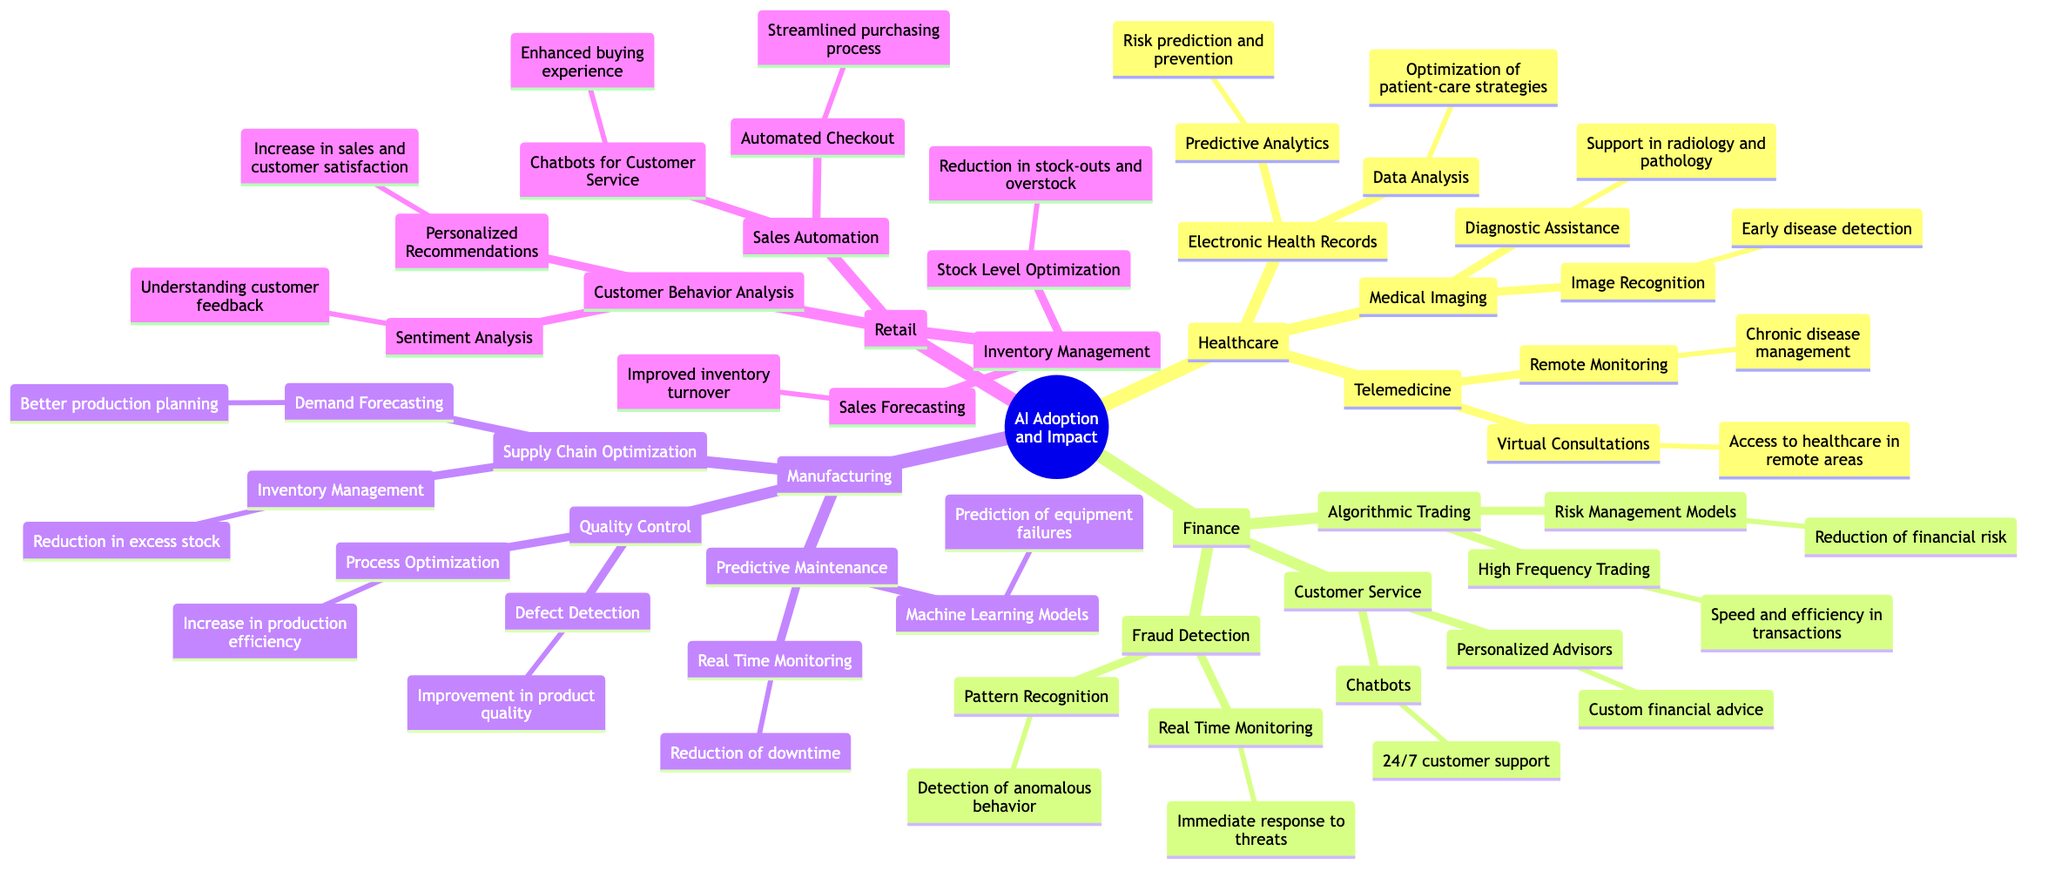What is one application of AI in healthcare? The diagram shows several applications in healthcare under various categories. One application listed is "Optimization of patient-care strategies," which falls under Electronic Health Records.
Answer: Optimization of patient-care strategies How many main industries are represented in the diagram? By looking at the root category, we can identify four main industries: Healthcare, Finance, Manufacturing, and Retail. Therefore, we count these categories.
Answer: Four Which sub-element in Finance is focused on immediate responses to threats? We can trace through the Finance section. In Fraud Detection, one of the sub-elements is "Real Time Monitoring," which is explicitly stated to provide immediate responses to threats.
Answer: Real Time Monitoring What is a key focus of Customer Behavior Analysis in Retail? In the Retail section under Customer Behavior Analysis, two sub-elements are listed: "Personalized Recommendations" and "Sentiment Analysis." One of the key focuses is indicated as "Increase in sales and customer satisfaction."
Answer: Increase in sales and customer satisfaction What does Predictive Maintenance aim to achieve in Manufacturing? Looking at the Manufacturing section under Predictive Maintenance, we can see that it includes sub-elements like "Prediction of equipment failures" and "Reduction of downtime." This indicates that the aim of Predictive Maintenance is primarily to predict failures and minimize downtime.
Answer: Prediction of equipment failures and Reduction of downtime 